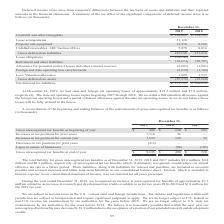According to Mantech International's financial document, How do deferred income taxes arise? from temporary differences between the tax basis of assets and liabilities and their reported amounts in the financial statements. The document states: "Deferred income taxes arise from temporary differences between the tax basis of assets and liabilities and their reported amounts in the financial sta..." Also, How much were the state and foreign net operating losses at December 31, 2019 respectively? The document shows two values: $12.2 million and $7.9 million. From the document: "and foreign net operating losses of approximately $12.2 million and $7.9 million, respectively. The state net operating losses expire beginning 2027 t..." Also, How much was the net deferred tax liabilities on December 31, 2018? According to the financial document, $108,956 (in thousands). The relevant text states: "(22,560) Net deferred tax liabilities $ 131,782 $ 108,956..." Also, can you calculate: What is the percentage change in net deferred tax liabilities from December 31, 2018, to 2019? To answer this question, I need to perform calculations using the financial data. The calculation is: ($131,782-$108,956)/$108,956 , which equals 20.95 (percentage). This is based on the information: "(55,376) (22,560) Net deferred tax liabilities $ 131,782 $ 108,956 (22,560) Net deferred tax liabilities $ 131,782 $ 108,956..." The key data points involved are: 108,956, 131,782. Also, can you calculate: What is the ratio of gross deferred tax to net deferred tax liabilities on December 31, 2018? Based on the calculation: 131,516/108,956 , the result is 1.21. This is based on the information: "(22,560) Net deferred tax liabilities $ 131,782 $ 108,956 ,878 8,816 Gross deferred tax liabilities 187,158 131,516 Lease obligations (34,146) — Retirement and other liabilities (18,614) (20,707) Allo..." The key data points involved are: 108,956, 131,516. Also, can you calculate: What is the proportion of the sum of lease arrangements and unbilled receivables over gross deferred tax liabilities on December 31, 2019? To answer this question, I need to perform calculations using the financial data. The calculation is: (31,128+ 5,878)/187,158 , which equals 0.2. This is based on the information: "0 8,168 Unbilled receivables - IRC Section 481(a) 5,878 8,816 Gross deferred tax liabilities 187,158 131,516 Lease obligations (34,146) — Retirement and ot ntangibles $ 136,882 $ 114,532 Lease arrange..." The key data points involved are: 187,158, 31,128, 5,878. 